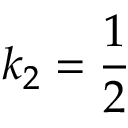Convert formula to latex. <formula><loc_0><loc_0><loc_500><loc_500>k _ { 2 } = \frac { 1 } { 2 }</formula> 